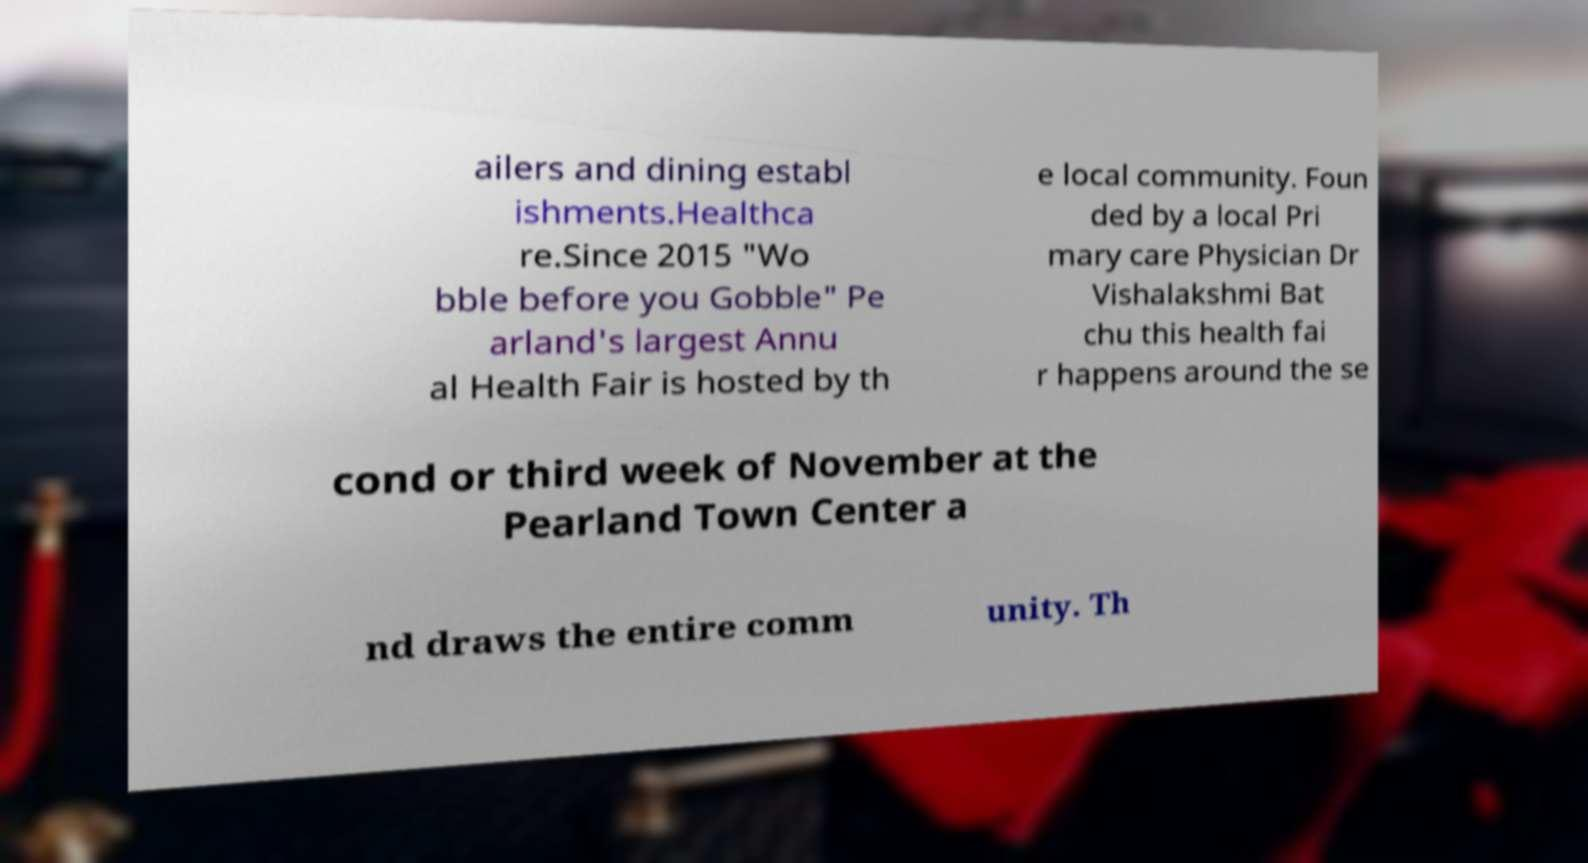Can you accurately transcribe the text from the provided image for me? ailers and dining establ ishments.Healthca re.Since 2015 "Wo bble before you Gobble" Pe arland's largest Annu al Health Fair is hosted by th e local community. Foun ded by a local Pri mary care Physician Dr Vishalakshmi Bat chu this health fai r happens around the se cond or third week of November at the Pearland Town Center a nd draws the entire comm unity. Th 